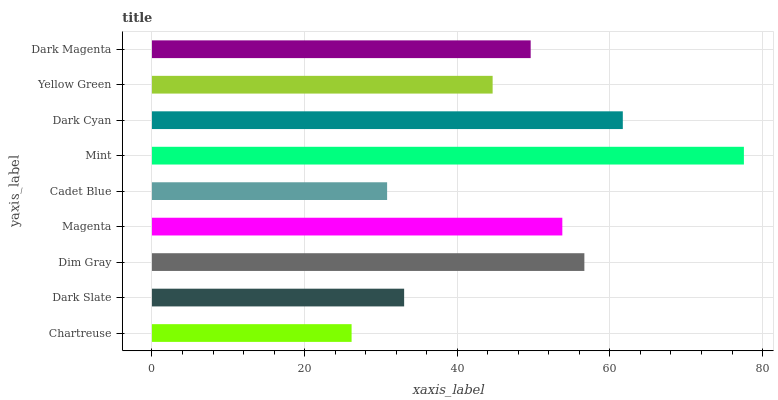Is Chartreuse the minimum?
Answer yes or no. Yes. Is Mint the maximum?
Answer yes or no. Yes. Is Dark Slate the minimum?
Answer yes or no. No. Is Dark Slate the maximum?
Answer yes or no. No. Is Dark Slate greater than Chartreuse?
Answer yes or no. Yes. Is Chartreuse less than Dark Slate?
Answer yes or no. Yes. Is Chartreuse greater than Dark Slate?
Answer yes or no. No. Is Dark Slate less than Chartreuse?
Answer yes or no. No. Is Dark Magenta the high median?
Answer yes or no. Yes. Is Dark Magenta the low median?
Answer yes or no. Yes. Is Dim Gray the high median?
Answer yes or no. No. Is Dim Gray the low median?
Answer yes or no. No. 